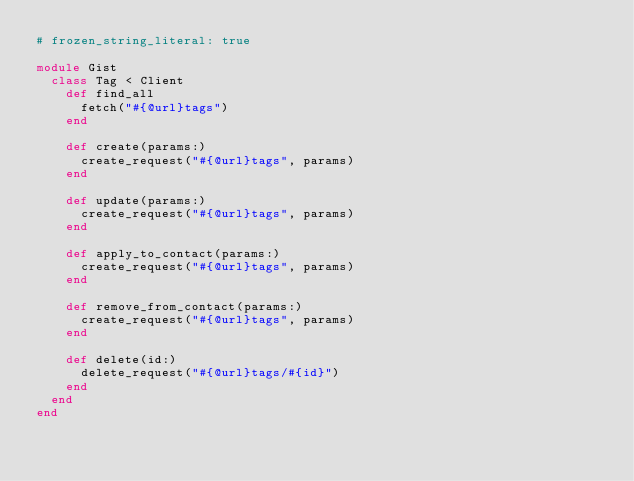Convert code to text. <code><loc_0><loc_0><loc_500><loc_500><_Ruby_># frozen_string_literal: true

module Gist
  class Tag < Client
    def find_all
      fetch("#{@url}tags")
    end

    def create(params:)
      create_request("#{@url}tags", params)
    end

    def update(params:)
      create_request("#{@url}tags", params)
    end

    def apply_to_contact(params:)
      create_request("#{@url}tags", params)
    end

    def remove_from_contact(params:)
      create_request("#{@url}tags", params)
    end

    def delete(id:)
      delete_request("#{@url}tags/#{id}")
    end
  end
end
</code> 